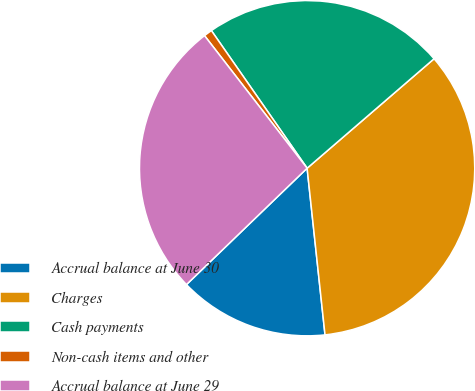Convert chart to OTSL. <chart><loc_0><loc_0><loc_500><loc_500><pie_chart><fcel>Accrual balance at June 30<fcel>Charges<fcel>Cash payments<fcel>Non-cash items and other<fcel>Accrual balance at June 29<nl><fcel>14.49%<fcel>34.62%<fcel>23.35%<fcel>0.81%<fcel>26.73%<nl></chart> 